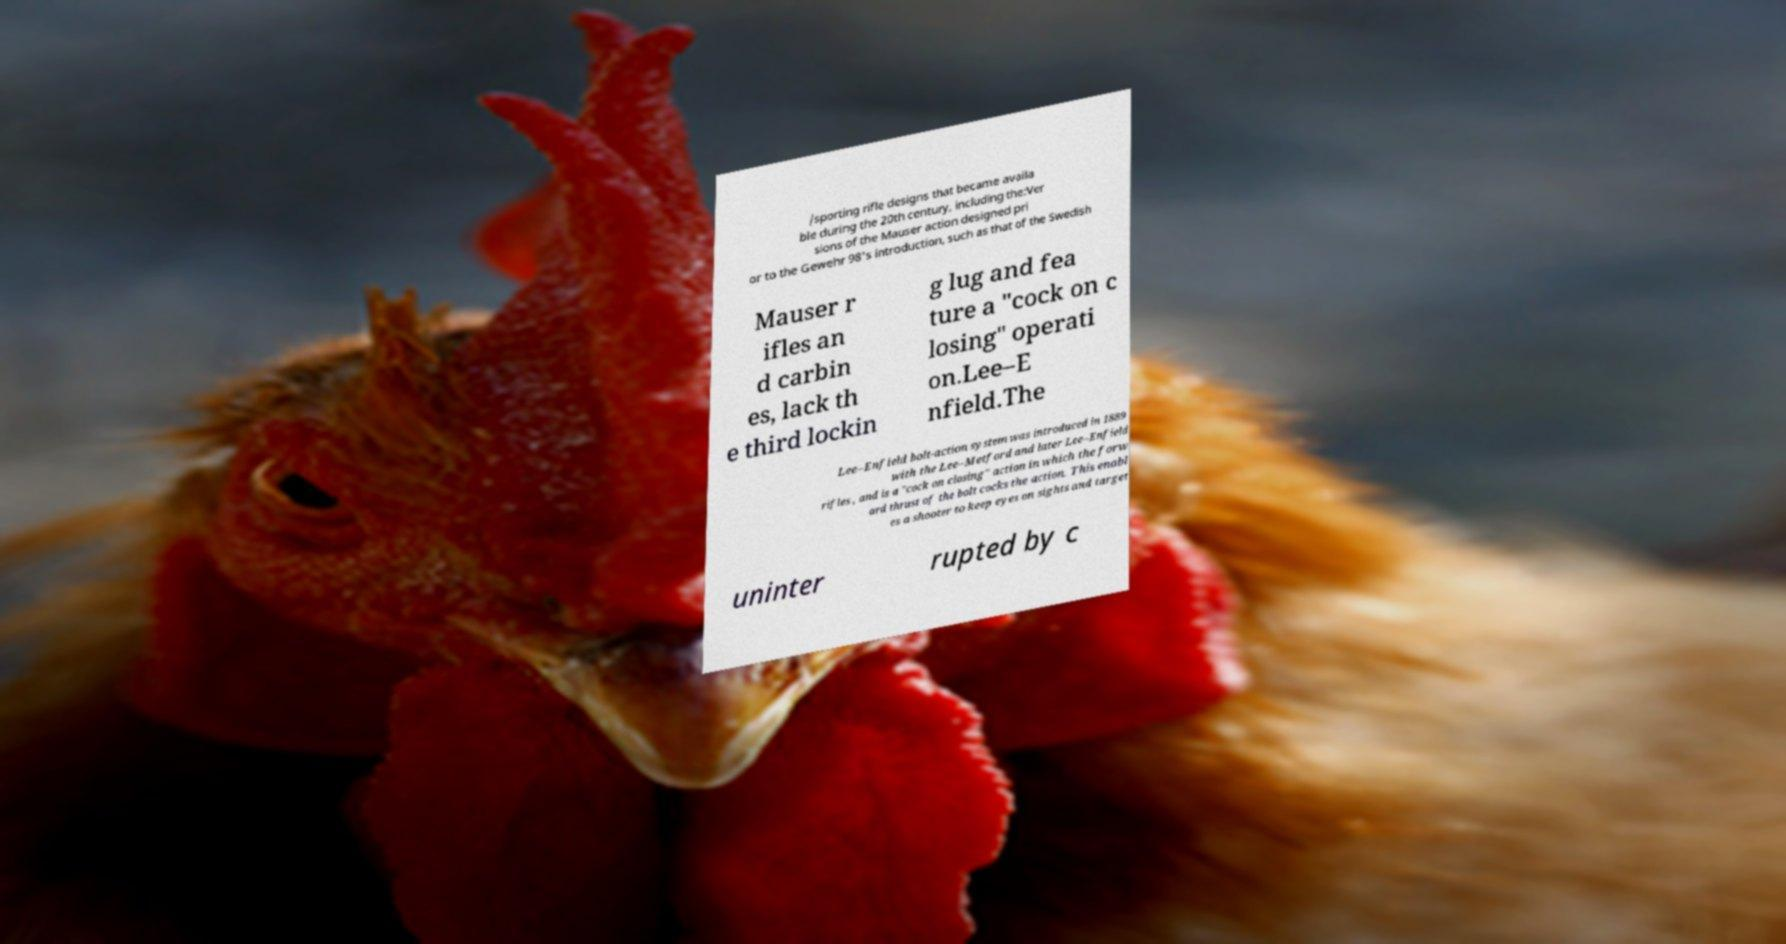Could you extract and type out the text from this image? /sporting rifle designs that became availa ble during the 20th century, including the:Ver sions of the Mauser action designed pri or to the Gewehr 98's introduction, such as that of the Swedish Mauser r ifles an d carbin es, lack th e third lockin g lug and fea ture a "cock on c losing" operati on.Lee–E nfield.The Lee–Enfield bolt-action system was introduced in 1889 with the Lee–Metford and later Lee–Enfield rifles , and is a "cock on closing" action in which the forw ard thrust of the bolt cocks the action. This enabl es a shooter to keep eyes on sights and target uninter rupted by c 